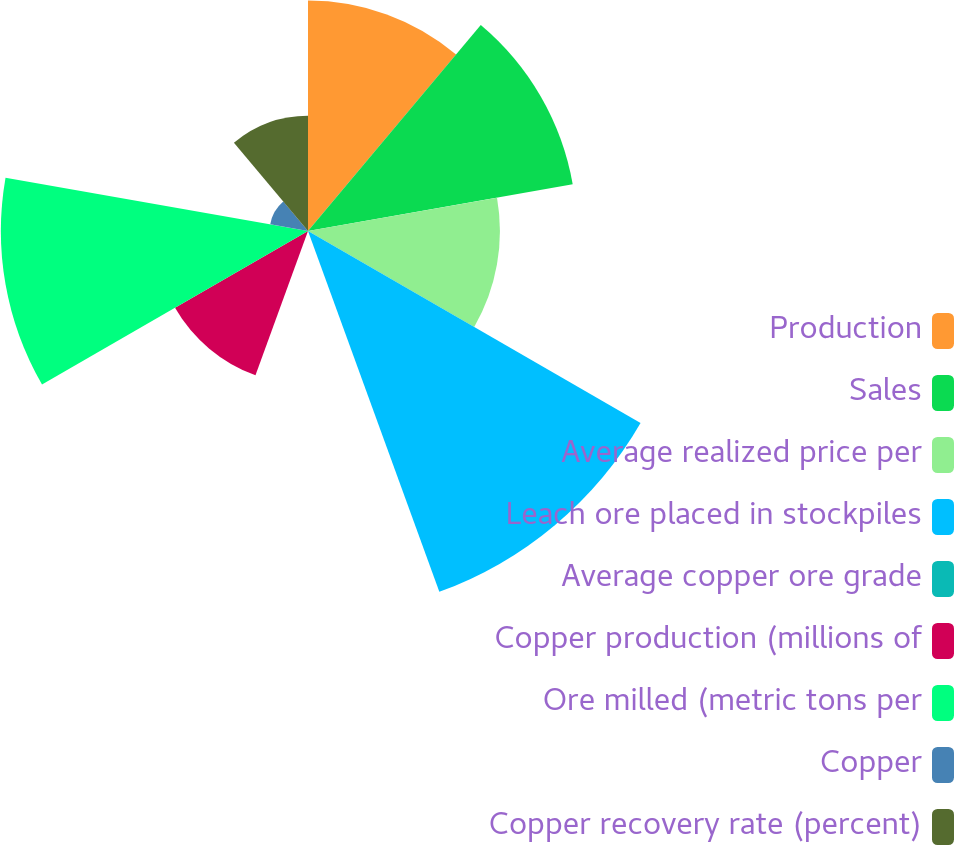Convert chart. <chart><loc_0><loc_0><loc_500><loc_500><pie_chart><fcel>Production<fcel>Sales<fcel>Average realized price per<fcel>Leach ore placed in stockpiles<fcel>Average copper ore grade<fcel>Copper production (millions of<fcel>Ore milled (metric tons per<fcel>Copper<fcel>Copper recovery rate (percent)<nl><fcel>13.64%<fcel>15.91%<fcel>11.36%<fcel>22.73%<fcel>0.0%<fcel>9.09%<fcel>18.18%<fcel>2.27%<fcel>6.82%<nl></chart> 